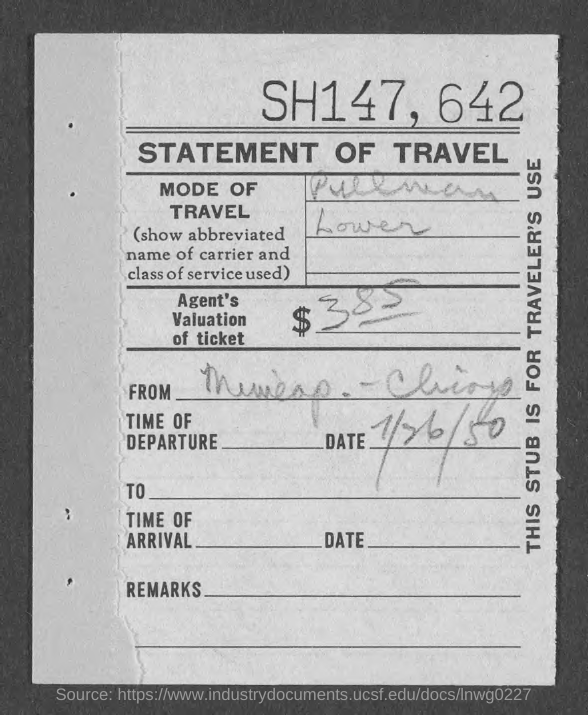Identify some key points in this picture. The agent has assessed the value of the ticket to be $385. The title of the document is 'Statement of Travel,' which declares the details of a travel-related matter. 